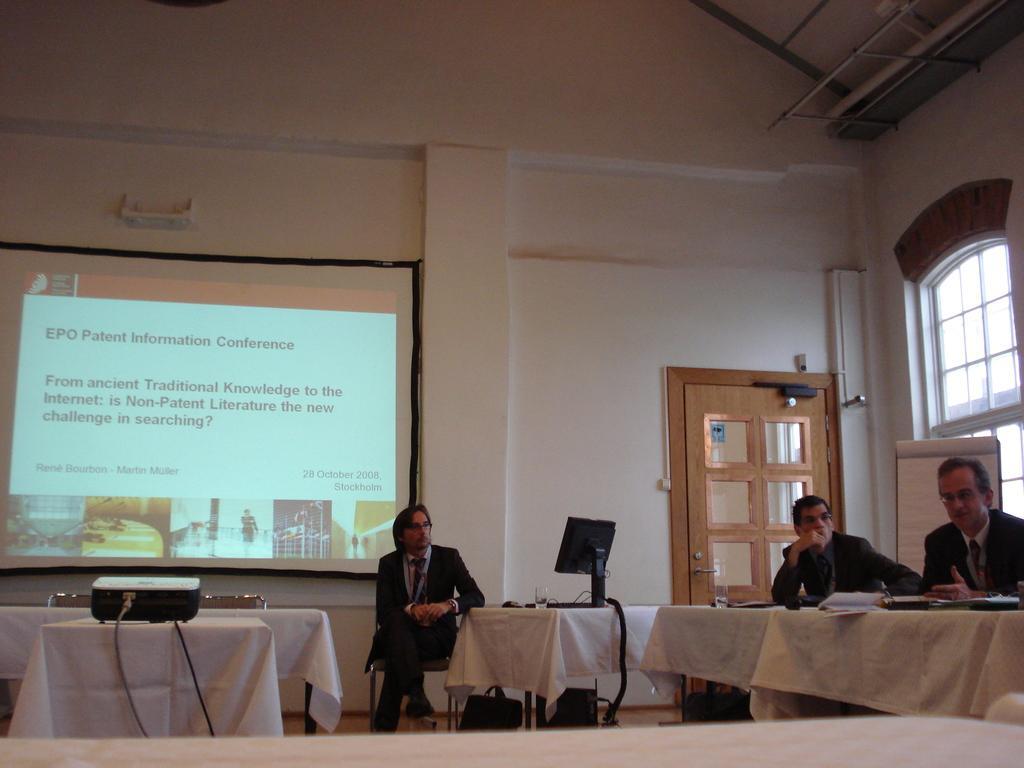Could you give a brief overview of what you see in this image? this picture shows few people seated on the chairs and we see a table and few papers on it and we see a monitor and a projector screen and a projector 